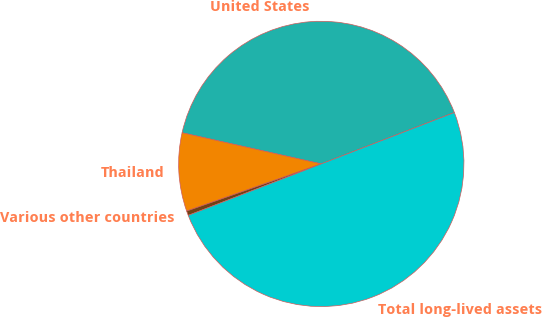<chart> <loc_0><loc_0><loc_500><loc_500><pie_chart><fcel>United States<fcel>Thailand<fcel>Various other countries<fcel>Total long-lived assets<nl><fcel>40.63%<fcel>8.87%<fcel>0.51%<fcel>50.0%<nl></chart> 